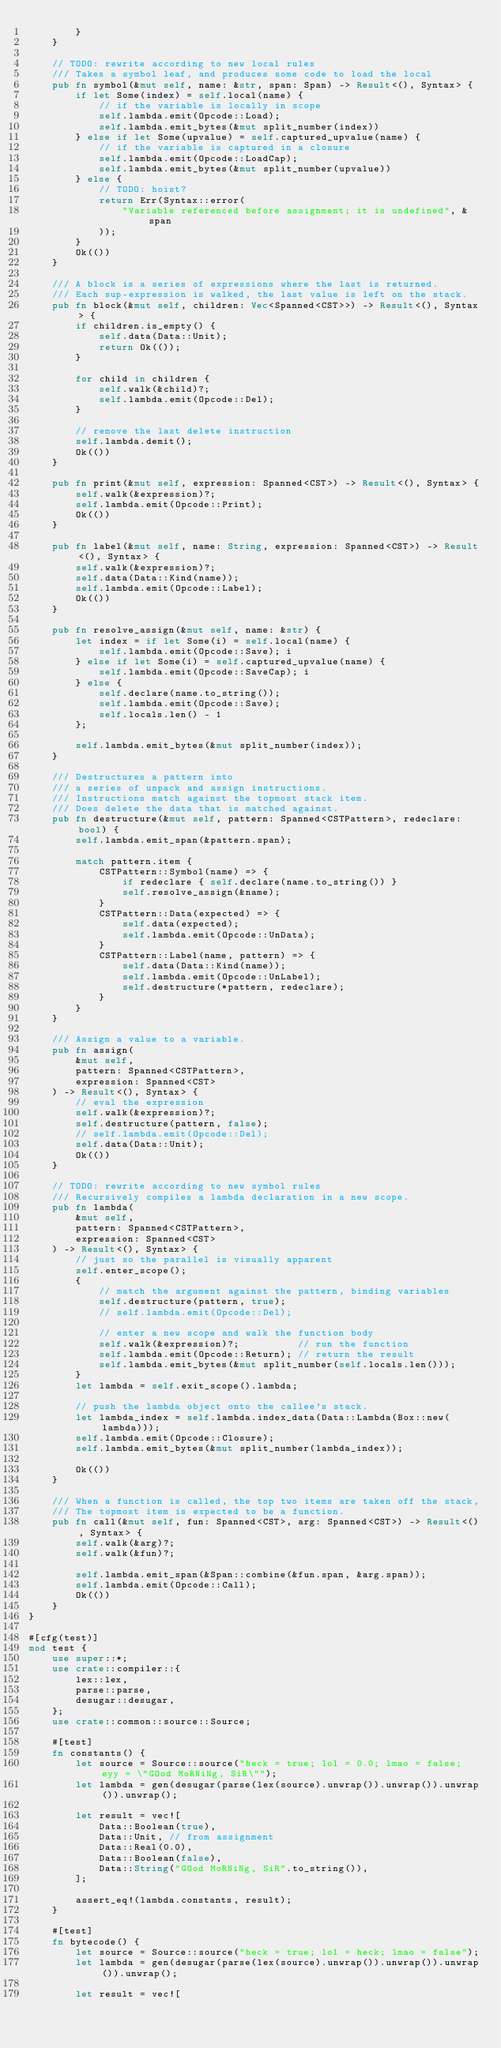<code> <loc_0><loc_0><loc_500><loc_500><_Rust_>        }
    }

    // TODO: rewrite according to new local rules
    /// Takes a symbol leaf, and produces some code to load the local
    pub fn symbol(&mut self, name: &str, span: Span) -> Result<(), Syntax> {
        if let Some(index) = self.local(name) {
            // if the variable is locally in scope
            self.lambda.emit(Opcode::Load);
            self.lambda.emit_bytes(&mut split_number(index))
        } else if let Some(upvalue) = self.captured_upvalue(name) {
            // if the variable is captured in a closure
            self.lambda.emit(Opcode::LoadCap);
            self.lambda.emit_bytes(&mut split_number(upvalue))
        } else {
            // TODO: hoist?
            return Err(Syntax::error(
                "Variable referenced before assignment; it is undefined", &span
            ));
        }
        Ok(())
    }

    /// A block is a series of expressions where the last is returned.
    /// Each sup-expression is walked, the last value is left on the stack.
    pub fn block(&mut self, children: Vec<Spanned<CST>>) -> Result<(), Syntax> {
        if children.is_empty() {
            self.data(Data::Unit);
            return Ok(());
        }

        for child in children {
            self.walk(&child)?;
            self.lambda.emit(Opcode::Del);
        }

        // remove the last delete instruction
        self.lambda.demit();
        Ok(())
    }

    pub fn print(&mut self, expression: Spanned<CST>) -> Result<(), Syntax> {
        self.walk(&expression)?;
        self.lambda.emit(Opcode::Print);
        Ok(())
    }

    pub fn label(&mut self, name: String, expression: Spanned<CST>) -> Result<(), Syntax> {
        self.walk(&expression)?;
        self.data(Data::Kind(name));
        self.lambda.emit(Opcode::Label);
        Ok(())
    }

    pub fn resolve_assign(&mut self, name: &str) {
        let index = if let Some(i) = self.local(name) {
            self.lambda.emit(Opcode::Save); i
        } else if let Some(i) = self.captured_upvalue(name) {
            self.lambda.emit(Opcode::SaveCap); i
        } else {
            self.declare(name.to_string());
            self.lambda.emit(Opcode::Save);
            self.locals.len() - 1
        };

        self.lambda.emit_bytes(&mut split_number(index));
    }

    /// Destructures a pattern into
    /// a series of unpack and assign instructions.
    /// Instructions match against the topmost stack item.
    /// Does delete the data that is matched against.
    pub fn destructure(&mut self, pattern: Spanned<CSTPattern>, redeclare: bool) {
        self.lambda.emit_span(&pattern.span);

        match pattern.item {
            CSTPattern::Symbol(name) => {
                if redeclare { self.declare(name.to_string()) }
                self.resolve_assign(&name);
            }
            CSTPattern::Data(expected) => {
                self.data(expected);
                self.lambda.emit(Opcode::UnData);
            }
            CSTPattern::Label(name, pattern) => {
                self.data(Data::Kind(name));
                self.lambda.emit(Opcode::UnLabel);
                self.destructure(*pattern, redeclare);
            }
        }
    }

    /// Assign a value to a variable.
    pub fn assign(
        &mut self,
        pattern: Spanned<CSTPattern>,
        expression: Spanned<CST>
    ) -> Result<(), Syntax> {
        // eval the expression
        self.walk(&expression)?;
        self.destructure(pattern, false);
        // self.lambda.emit(Opcode::Del);
        self.data(Data::Unit);
        Ok(())
    }

    // TODO: rewrite according to new symbol rules
    /// Recursively compiles a lambda declaration in a new scope.
    pub fn lambda(
        &mut self,
        pattern: Spanned<CSTPattern>,
        expression: Spanned<CST>
    ) -> Result<(), Syntax> {
        // just so the parallel is visually apparent
        self.enter_scope();
        {
            // match the argument against the pattern, binding variables
            self.destructure(pattern, true);
            // self.lambda.emit(Opcode::Del);

            // enter a new scope and walk the function body
            self.walk(&expression)?;          // run the function
            self.lambda.emit(Opcode::Return); // return the result
            self.lambda.emit_bytes(&mut split_number(self.locals.len()));
        }
        let lambda = self.exit_scope().lambda;

        // push the lambda object onto the callee's stack.
        let lambda_index = self.lambda.index_data(Data::Lambda(Box::new(lambda)));
        self.lambda.emit(Opcode::Closure);
        self.lambda.emit_bytes(&mut split_number(lambda_index));

        Ok(())
    }

    /// When a function is called, the top two items are taken off the stack,
    /// The topmost item is expected to be a function.
    pub fn call(&mut self, fun: Spanned<CST>, arg: Spanned<CST>) -> Result<(), Syntax> {
        self.walk(&arg)?;
        self.walk(&fun)?;

        self.lambda.emit_span(&Span::combine(&fun.span, &arg.span));
        self.lambda.emit(Opcode::Call);
        Ok(())
    }
}

#[cfg(test)]
mod test {
    use super::*;
    use crate::compiler::{
        lex::lex,
        parse::parse,
        desugar::desugar,
    };
    use crate::common::source::Source;

    #[test]
    fn constants() {
        let source = Source::source("heck = true; lol = 0.0; lmao = false; eyy = \"GOod MoRNiNg, SiR\"");
        let lambda = gen(desugar(parse(lex(source).unwrap()).unwrap()).unwrap()).unwrap();

        let result = vec![
            Data::Boolean(true),
            Data::Unit, // from assignment
            Data::Real(0.0),
            Data::Boolean(false),
            Data::String("GOod MoRNiNg, SiR".to_string()),
        ];

        assert_eq!(lambda.constants, result);
    }

    #[test]
    fn bytecode() {
        let source = Source::source("heck = true; lol = heck; lmao = false");
        let lambda = gen(desugar(parse(lex(source).unwrap()).unwrap()).unwrap()).unwrap();

        let result = vec![</code> 